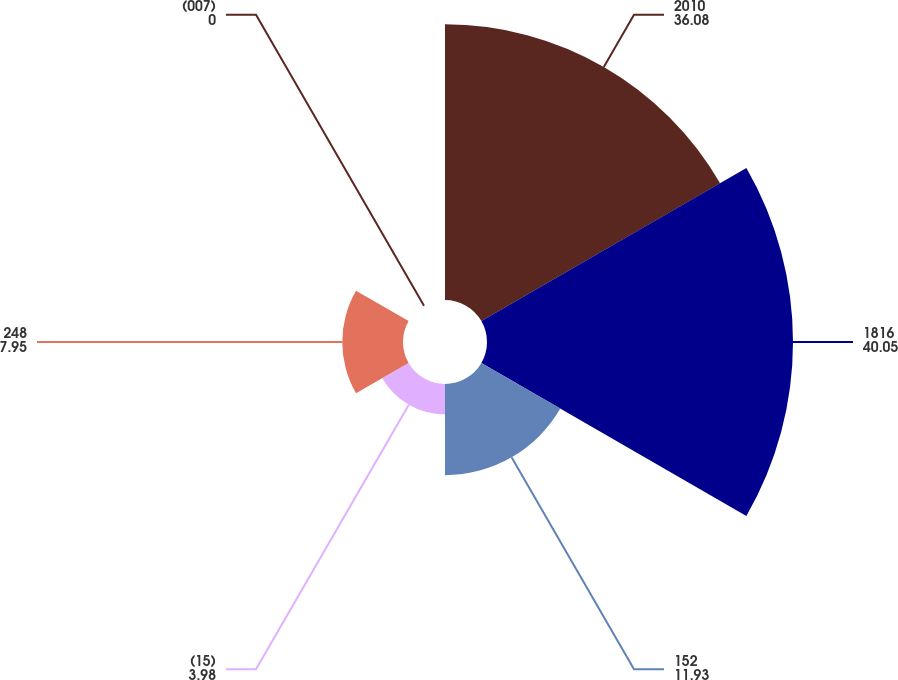<chart> <loc_0><loc_0><loc_500><loc_500><pie_chart><fcel>2010<fcel>1816<fcel>152<fcel>(15)<fcel>248<fcel>(007)<nl><fcel>36.08%<fcel>40.05%<fcel>11.93%<fcel>3.98%<fcel>7.95%<fcel>0.0%<nl></chart> 